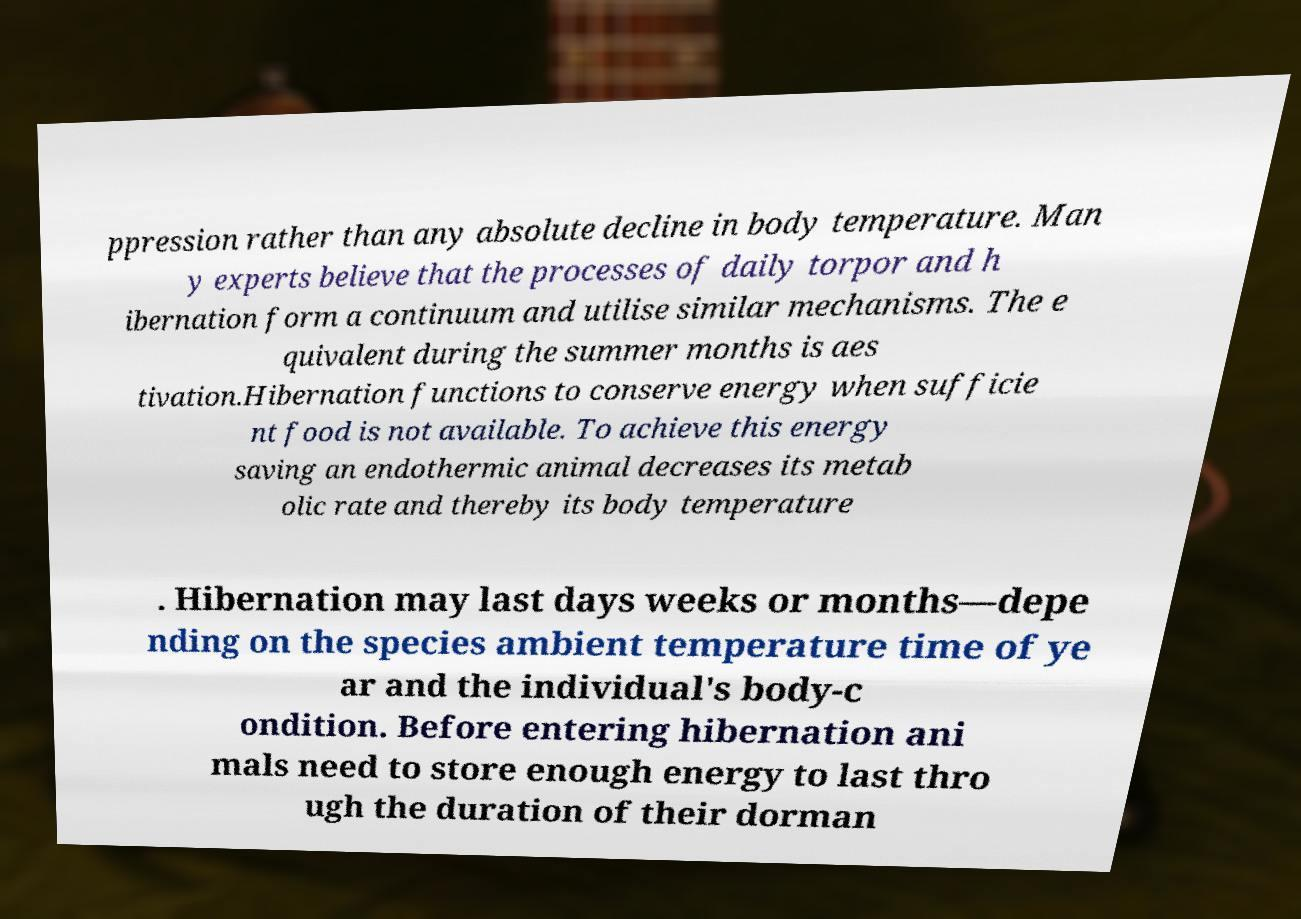Please read and relay the text visible in this image. What does it say? ppression rather than any absolute decline in body temperature. Man y experts believe that the processes of daily torpor and h ibernation form a continuum and utilise similar mechanisms. The e quivalent during the summer months is aes tivation.Hibernation functions to conserve energy when sufficie nt food is not available. To achieve this energy saving an endothermic animal decreases its metab olic rate and thereby its body temperature . Hibernation may last days weeks or months—depe nding on the species ambient temperature time of ye ar and the individual's body-c ondition. Before entering hibernation ani mals need to store enough energy to last thro ugh the duration of their dorman 